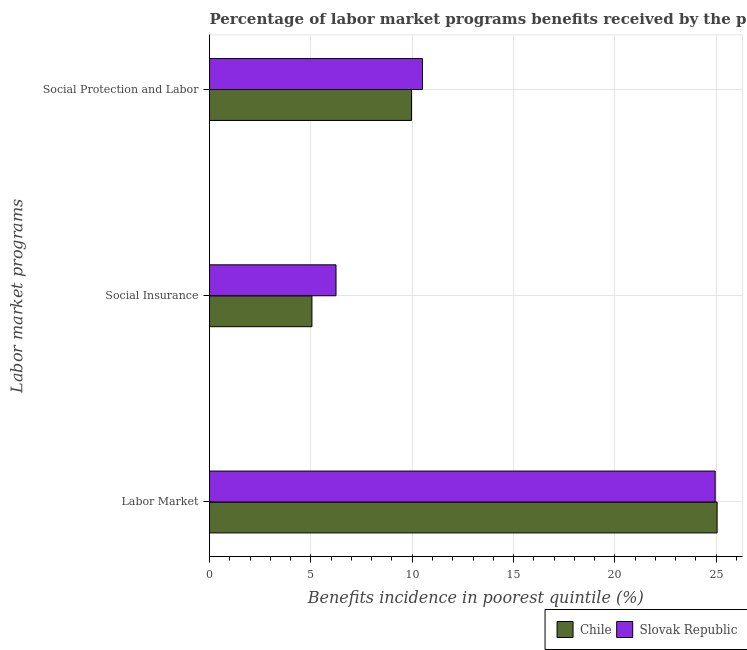How many different coloured bars are there?
Your answer should be very brief. 2. What is the label of the 2nd group of bars from the top?
Keep it short and to the point. Social Insurance. What is the percentage of benefits received due to social protection programs in Chile?
Provide a short and direct response. 9.97. Across all countries, what is the maximum percentage of benefits received due to social insurance programs?
Ensure brevity in your answer.  6.24. Across all countries, what is the minimum percentage of benefits received due to social protection programs?
Your answer should be very brief. 9.97. In which country was the percentage of benefits received due to social protection programs maximum?
Offer a terse response. Slovak Republic. In which country was the percentage of benefits received due to labor market programs minimum?
Ensure brevity in your answer.  Slovak Republic. What is the total percentage of benefits received due to social protection programs in the graph?
Your answer should be very brief. 20.47. What is the difference between the percentage of benefits received due to labor market programs in Chile and that in Slovak Republic?
Offer a very short reply. 0.1. What is the difference between the percentage of benefits received due to labor market programs in Slovak Republic and the percentage of benefits received due to social protection programs in Chile?
Offer a terse response. 14.98. What is the average percentage of benefits received due to labor market programs per country?
Your answer should be compact. 25. What is the difference between the percentage of benefits received due to social protection programs and percentage of benefits received due to labor market programs in Chile?
Give a very brief answer. -15.08. In how many countries, is the percentage of benefits received due to social protection programs greater than 25 %?
Offer a very short reply. 0. What is the ratio of the percentage of benefits received due to social insurance programs in Chile to that in Slovak Republic?
Your response must be concise. 0.81. What is the difference between the highest and the second highest percentage of benefits received due to social protection programs?
Offer a very short reply. 0.54. What is the difference between the highest and the lowest percentage of benefits received due to labor market programs?
Your response must be concise. 0.1. In how many countries, is the percentage of benefits received due to social protection programs greater than the average percentage of benefits received due to social protection programs taken over all countries?
Your response must be concise. 1. What does the 2nd bar from the top in Labor Market represents?
Provide a succinct answer. Chile. Is it the case that in every country, the sum of the percentage of benefits received due to labor market programs and percentage of benefits received due to social insurance programs is greater than the percentage of benefits received due to social protection programs?
Offer a terse response. Yes. Where does the legend appear in the graph?
Keep it short and to the point. Bottom right. What is the title of the graph?
Your response must be concise. Percentage of labor market programs benefits received by the poorest 20% of the population of countries. Does "Latin America(developing only)" appear as one of the legend labels in the graph?
Make the answer very short. No. What is the label or title of the X-axis?
Your response must be concise. Benefits incidence in poorest quintile (%). What is the label or title of the Y-axis?
Offer a terse response. Labor market programs. What is the Benefits incidence in poorest quintile (%) in Chile in Labor Market?
Provide a succinct answer. 25.05. What is the Benefits incidence in poorest quintile (%) of Slovak Republic in Labor Market?
Offer a very short reply. 24.95. What is the Benefits incidence in poorest quintile (%) of Chile in Social Insurance?
Make the answer very short. 5.05. What is the Benefits incidence in poorest quintile (%) of Slovak Republic in Social Insurance?
Make the answer very short. 6.24. What is the Benefits incidence in poorest quintile (%) in Chile in Social Protection and Labor?
Offer a terse response. 9.97. What is the Benefits incidence in poorest quintile (%) of Slovak Republic in Social Protection and Labor?
Provide a short and direct response. 10.5. Across all Labor market programs, what is the maximum Benefits incidence in poorest quintile (%) in Chile?
Ensure brevity in your answer.  25.05. Across all Labor market programs, what is the maximum Benefits incidence in poorest quintile (%) of Slovak Republic?
Your answer should be very brief. 24.95. Across all Labor market programs, what is the minimum Benefits incidence in poorest quintile (%) of Chile?
Offer a terse response. 5.05. Across all Labor market programs, what is the minimum Benefits incidence in poorest quintile (%) of Slovak Republic?
Offer a terse response. 6.24. What is the total Benefits incidence in poorest quintile (%) of Chile in the graph?
Give a very brief answer. 40.06. What is the total Benefits incidence in poorest quintile (%) of Slovak Republic in the graph?
Keep it short and to the point. 41.7. What is the difference between the Benefits incidence in poorest quintile (%) of Chile in Labor Market and that in Social Insurance?
Ensure brevity in your answer.  19.99. What is the difference between the Benefits incidence in poorest quintile (%) in Slovak Republic in Labor Market and that in Social Insurance?
Provide a short and direct response. 18.71. What is the difference between the Benefits incidence in poorest quintile (%) of Chile in Labor Market and that in Social Protection and Labor?
Your answer should be very brief. 15.08. What is the difference between the Benefits incidence in poorest quintile (%) in Slovak Republic in Labor Market and that in Social Protection and Labor?
Offer a terse response. 14.44. What is the difference between the Benefits incidence in poorest quintile (%) of Chile in Social Insurance and that in Social Protection and Labor?
Ensure brevity in your answer.  -4.91. What is the difference between the Benefits incidence in poorest quintile (%) in Slovak Republic in Social Insurance and that in Social Protection and Labor?
Provide a succinct answer. -4.26. What is the difference between the Benefits incidence in poorest quintile (%) of Chile in Labor Market and the Benefits incidence in poorest quintile (%) of Slovak Republic in Social Insurance?
Provide a succinct answer. 18.8. What is the difference between the Benefits incidence in poorest quintile (%) in Chile in Labor Market and the Benefits incidence in poorest quintile (%) in Slovak Republic in Social Protection and Labor?
Offer a terse response. 14.54. What is the difference between the Benefits incidence in poorest quintile (%) in Chile in Social Insurance and the Benefits incidence in poorest quintile (%) in Slovak Republic in Social Protection and Labor?
Provide a succinct answer. -5.45. What is the average Benefits incidence in poorest quintile (%) of Chile per Labor market programs?
Provide a short and direct response. 13.35. What is the average Benefits incidence in poorest quintile (%) of Slovak Republic per Labor market programs?
Make the answer very short. 13.9. What is the difference between the Benefits incidence in poorest quintile (%) in Chile and Benefits incidence in poorest quintile (%) in Slovak Republic in Labor Market?
Your response must be concise. 0.1. What is the difference between the Benefits incidence in poorest quintile (%) of Chile and Benefits incidence in poorest quintile (%) of Slovak Republic in Social Insurance?
Give a very brief answer. -1.19. What is the difference between the Benefits incidence in poorest quintile (%) of Chile and Benefits incidence in poorest quintile (%) of Slovak Republic in Social Protection and Labor?
Ensure brevity in your answer.  -0.54. What is the ratio of the Benefits incidence in poorest quintile (%) of Chile in Labor Market to that in Social Insurance?
Offer a very short reply. 4.96. What is the ratio of the Benefits incidence in poorest quintile (%) in Slovak Republic in Labor Market to that in Social Insurance?
Your answer should be compact. 4. What is the ratio of the Benefits incidence in poorest quintile (%) in Chile in Labor Market to that in Social Protection and Labor?
Ensure brevity in your answer.  2.51. What is the ratio of the Benefits incidence in poorest quintile (%) in Slovak Republic in Labor Market to that in Social Protection and Labor?
Your response must be concise. 2.38. What is the ratio of the Benefits incidence in poorest quintile (%) in Chile in Social Insurance to that in Social Protection and Labor?
Make the answer very short. 0.51. What is the ratio of the Benefits incidence in poorest quintile (%) of Slovak Republic in Social Insurance to that in Social Protection and Labor?
Give a very brief answer. 0.59. What is the difference between the highest and the second highest Benefits incidence in poorest quintile (%) in Chile?
Your answer should be compact. 15.08. What is the difference between the highest and the second highest Benefits incidence in poorest quintile (%) of Slovak Republic?
Provide a succinct answer. 14.44. What is the difference between the highest and the lowest Benefits incidence in poorest quintile (%) of Chile?
Your response must be concise. 19.99. What is the difference between the highest and the lowest Benefits incidence in poorest quintile (%) in Slovak Republic?
Give a very brief answer. 18.71. 